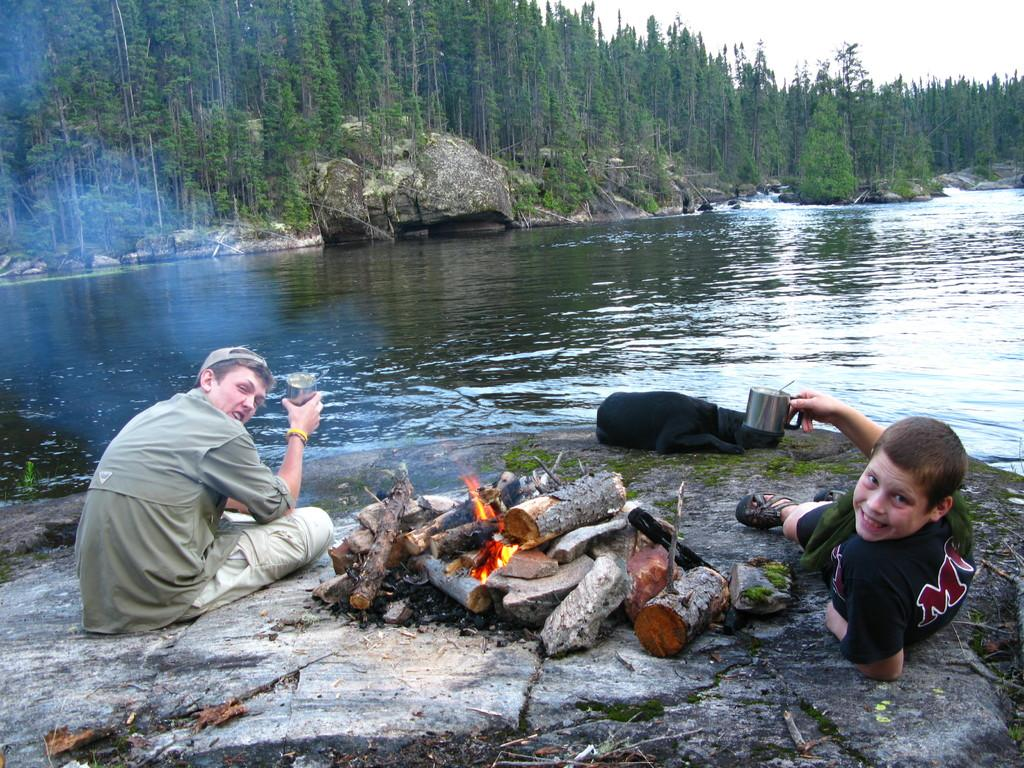How many boys are in the image? There are two boys in the image. What are the boys doing in the image? The boys are sitting and laying around a campfire. Where is the campfire located in the image? The campfire is on a rock. What natural feature can be seen in the background of the image? There is a lake in the image, and trees are visible behind the lake. What is visible above the scene in the image? The sky is visible above the scene. What type of breakfast is being served in the image? There is no breakfast present in the image; it features two boys sitting and laying around a campfire. 